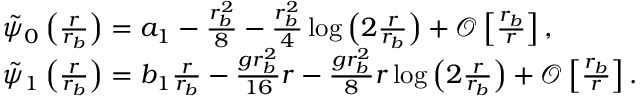Convert formula to latex. <formula><loc_0><loc_0><loc_500><loc_500>\begin{array} { r l } & { \tilde { \psi } _ { 0 } \left ( \frac { r } { r _ { b } } \right ) = a _ { 1 } - \frac { r _ { b } ^ { 2 } } { 8 } - \frac { r _ { b } ^ { 2 } } { 4 } \log \left ( 2 \frac { r } { r _ { b } } \right ) + \mathcal { O } \left [ \frac { r _ { b } } { r } \right ] , } \\ & { \tilde { \psi } _ { 1 } \left ( \frac { r } { r _ { b } } \right ) = b _ { 1 } \frac { r } { r _ { b } } - \frac { g r _ { b } ^ { 2 } } { 1 6 } r - \frac { g r _ { b } ^ { 2 } } { 8 } r \log \left ( 2 \frac { r } { r _ { b } } \right ) + \mathcal { O } \left [ \frac { r _ { b } } { r } \right ] . } \end{array}</formula> 